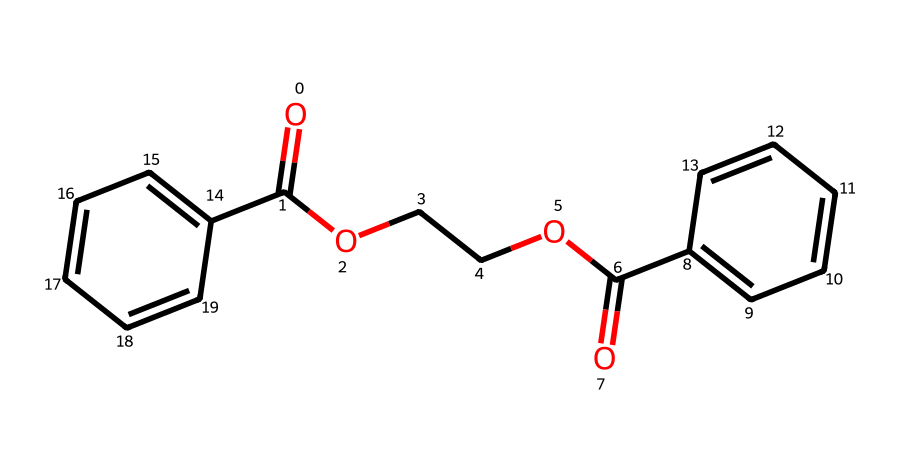What type of chemical is represented by this SMILES notation? The SMILES notation indicates that this compound is an ester due to the presence of the ester functional group (-COO-), which can be identified from the carbonyl group (C=O) adjacent to an ether bond (C-O).
Answer: ester How many carbon atoms are in the structure? By analyzing the SMILES, we can identify all carbon atoms within the molecular structure. There are a total of 13 carbon atoms found in the chain and aromatic rings.
Answer: 13 What are the aromatic components of this structure? The presence of "c1ccc(cc1)" in the SMILES refers to an aromatic ring consisting of 6 carbon atoms, making it an aromatic compound. There are two such fragments in the structure, confirming it contains two aromatic rings.
Answer: two How many ester linkages are present in this compound? The ester functional groups can be identified in the structure, where the carbonyl carbon is bonded to an oxygen atom followed by another carbon group. There is one ester linkage visible in the given SMILES.
Answer: one What property is likely enhanced in this polyester due to the presence of esters? Esters generally contribute to the flexibility and durability of the polymer structure, meaning the compound will likely exhibit enhanced flexibility which is desirable in sportswear.
Answer: flexibility What type of reactions can esters undergo? Esters can undergo hydrolysis to form carboxylic acids and alcohols, or they can participate in transesterification. These are characteristic reactions of esters due to their functional group.
Answer: hydrolysis How are the repeating units in this polyester structure established? The molecular composition indicates that the polyester is built by the repetition of ester links formed between the dicarboxylic acid and diol components. The repeating units are determined by the linkage pattern of the ester functional groups.
Answer: repeating units 